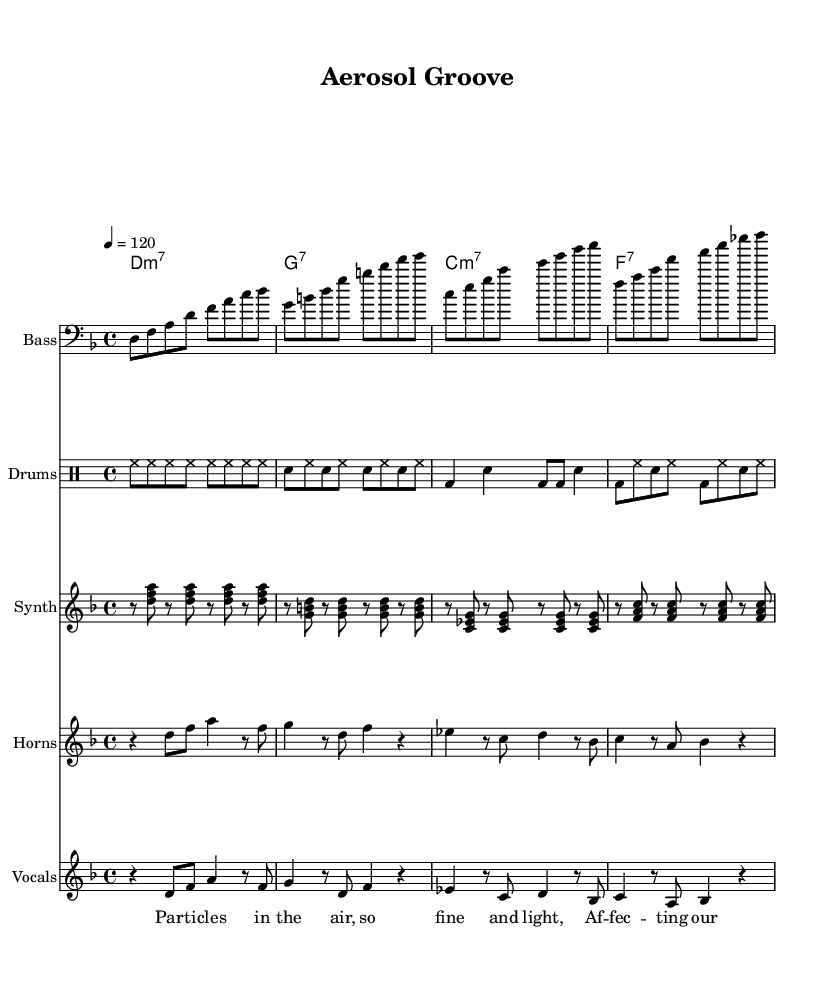What is the key signature of this music? The key signature is indicated at the beginning of the staff and shows two flats, which indicates D minor.
Answer: D minor What is the time signature of this piece? The time signature is located at the beginning of the score, indicating how many beats are in each measure. In this case, it shows a "4/4" which means there are four beats per measure.
Answer: 4/4 What is the tempo marking for the music? The tempo marking is indicated in beats per minute (bpm) at the beginning of the score. It states "4 = 120," which means a quarter note gets 120 beats per minute.
Answer: 120 How many sections are there in the lyrics? The lyrics consist of two distinct sections: a verse and a chorus. This is indicated by the different lyrical segments labeled accordingly in the score.
Answer: 2 What type of instrument is featured prominently in this piece? The score lists various parts, but "Bass" is the name of one specific instrument part prominently featured, which is commonly associated with funk music.
Answer: Bass What is the chord progression used in this music? The chord progression is written in the chord names section and shows a series of chords that follow a specific sequence. Here, the progression starts with D minor 7, followed by G7, C minor 7, and ends with F7.
Answer: D minor 7, G7, C minor 7, F7 What style of music is this composition? The characteristics of the rhythm, upbeat tempo, and specific instruments such as bass and drums indicate that this is a funk fusion piece, combining elements of funk with other musical styles.
Answer: Funk fusion 